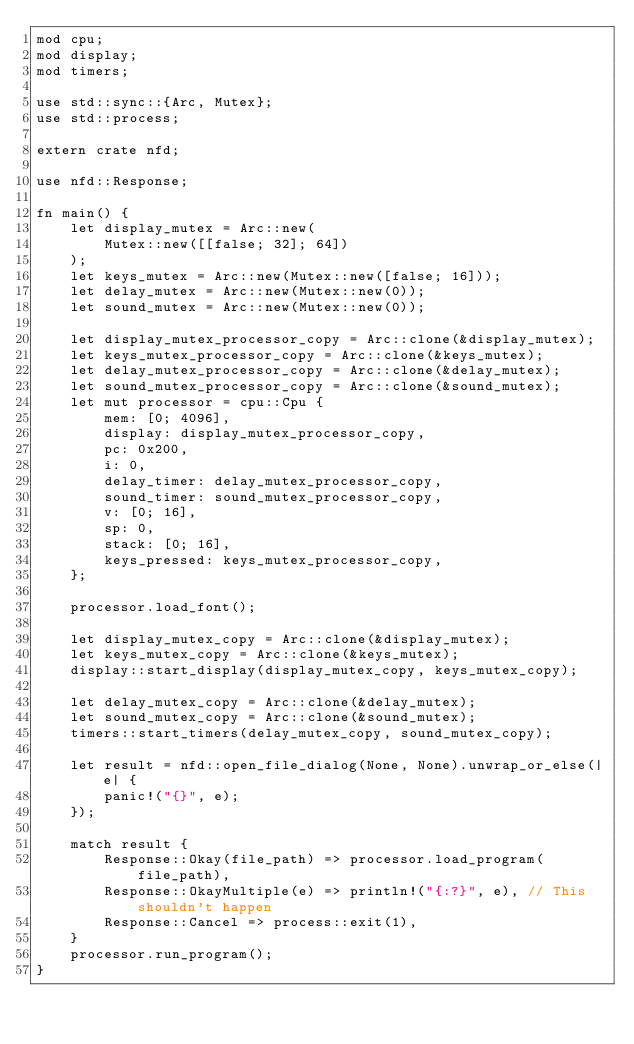Convert code to text. <code><loc_0><loc_0><loc_500><loc_500><_Rust_>mod cpu;
mod display;
mod timers;

use std::sync::{Arc, Mutex};
use std::process;

extern crate nfd;

use nfd::Response;

fn main() {
    let display_mutex = Arc::new(
        Mutex::new([[false; 32]; 64])
    );
    let keys_mutex = Arc::new(Mutex::new([false; 16]));
    let delay_mutex = Arc::new(Mutex::new(0));
    let sound_mutex = Arc::new(Mutex::new(0));

    let display_mutex_processor_copy = Arc::clone(&display_mutex);
    let keys_mutex_processor_copy = Arc::clone(&keys_mutex);
    let delay_mutex_processor_copy = Arc::clone(&delay_mutex);
    let sound_mutex_processor_copy = Arc::clone(&sound_mutex);
    let mut processor = cpu::Cpu {
        mem: [0; 4096],
        display: display_mutex_processor_copy,
        pc: 0x200,
        i: 0,
        delay_timer: delay_mutex_processor_copy,
        sound_timer: sound_mutex_processor_copy,
        v: [0; 16],
        sp: 0,
        stack: [0; 16],
        keys_pressed: keys_mutex_processor_copy,
    };

    processor.load_font();

    let display_mutex_copy = Arc::clone(&display_mutex);
    let keys_mutex_copy = Arc::clone(&keys_mutex);
    display::start_display(display_mutex_copy, keys_mutex_copy);

    let delay_mutex_copy = Arc::clone(&delay_mutex);
    let sound_mutex_copy = Arc::clone(&sound_mutex);
    timers::start_timers(delay_mutex_copy, sound_mutex_copy);

    let result = nfd::open_file_dialog(None, None).unwrap_or_else(|e| {
        panic!("{}", e);
    });
  
    match result {
        Response::Okay(file_path) => processor.load_program(file_path),
        Response::OkayMultiple(e) => println!("{:?}", e), // This shouldn't happen
        Response::Cancel => process::exit(1),
    }
    processor.run_program();
}
</code> 